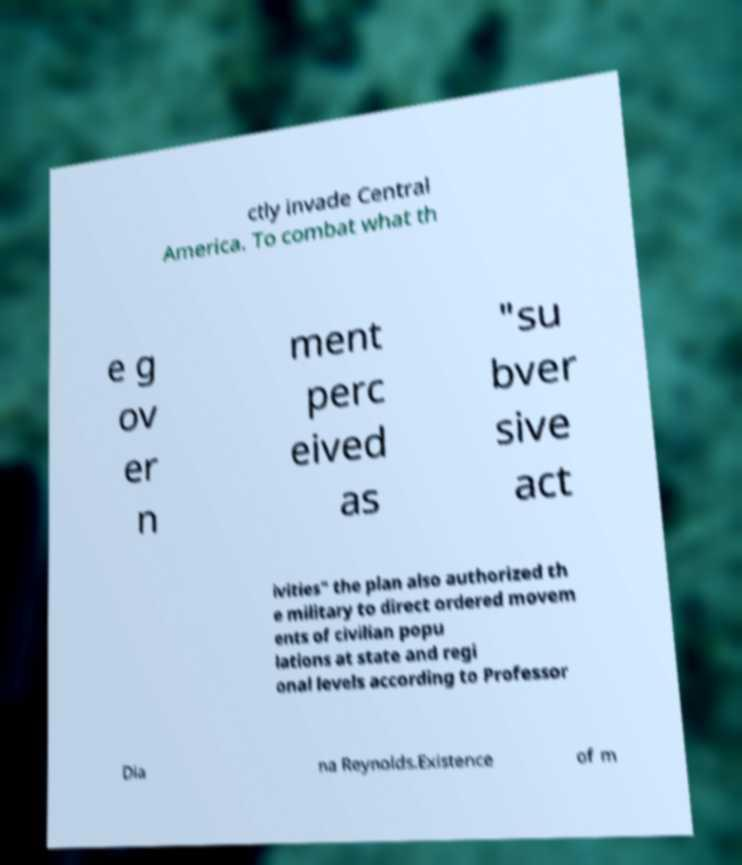Please read and relay the text visible in this image. What does it say? ctly invade Central America. To combat what th e g ov er n ment perc eived as "su bver sive act ivities" the plan also authorized th e military to direct ordered movem ents of civilian popu lations at state and regi onal levels according to Professor Dia na Reynolds.Existence of m 